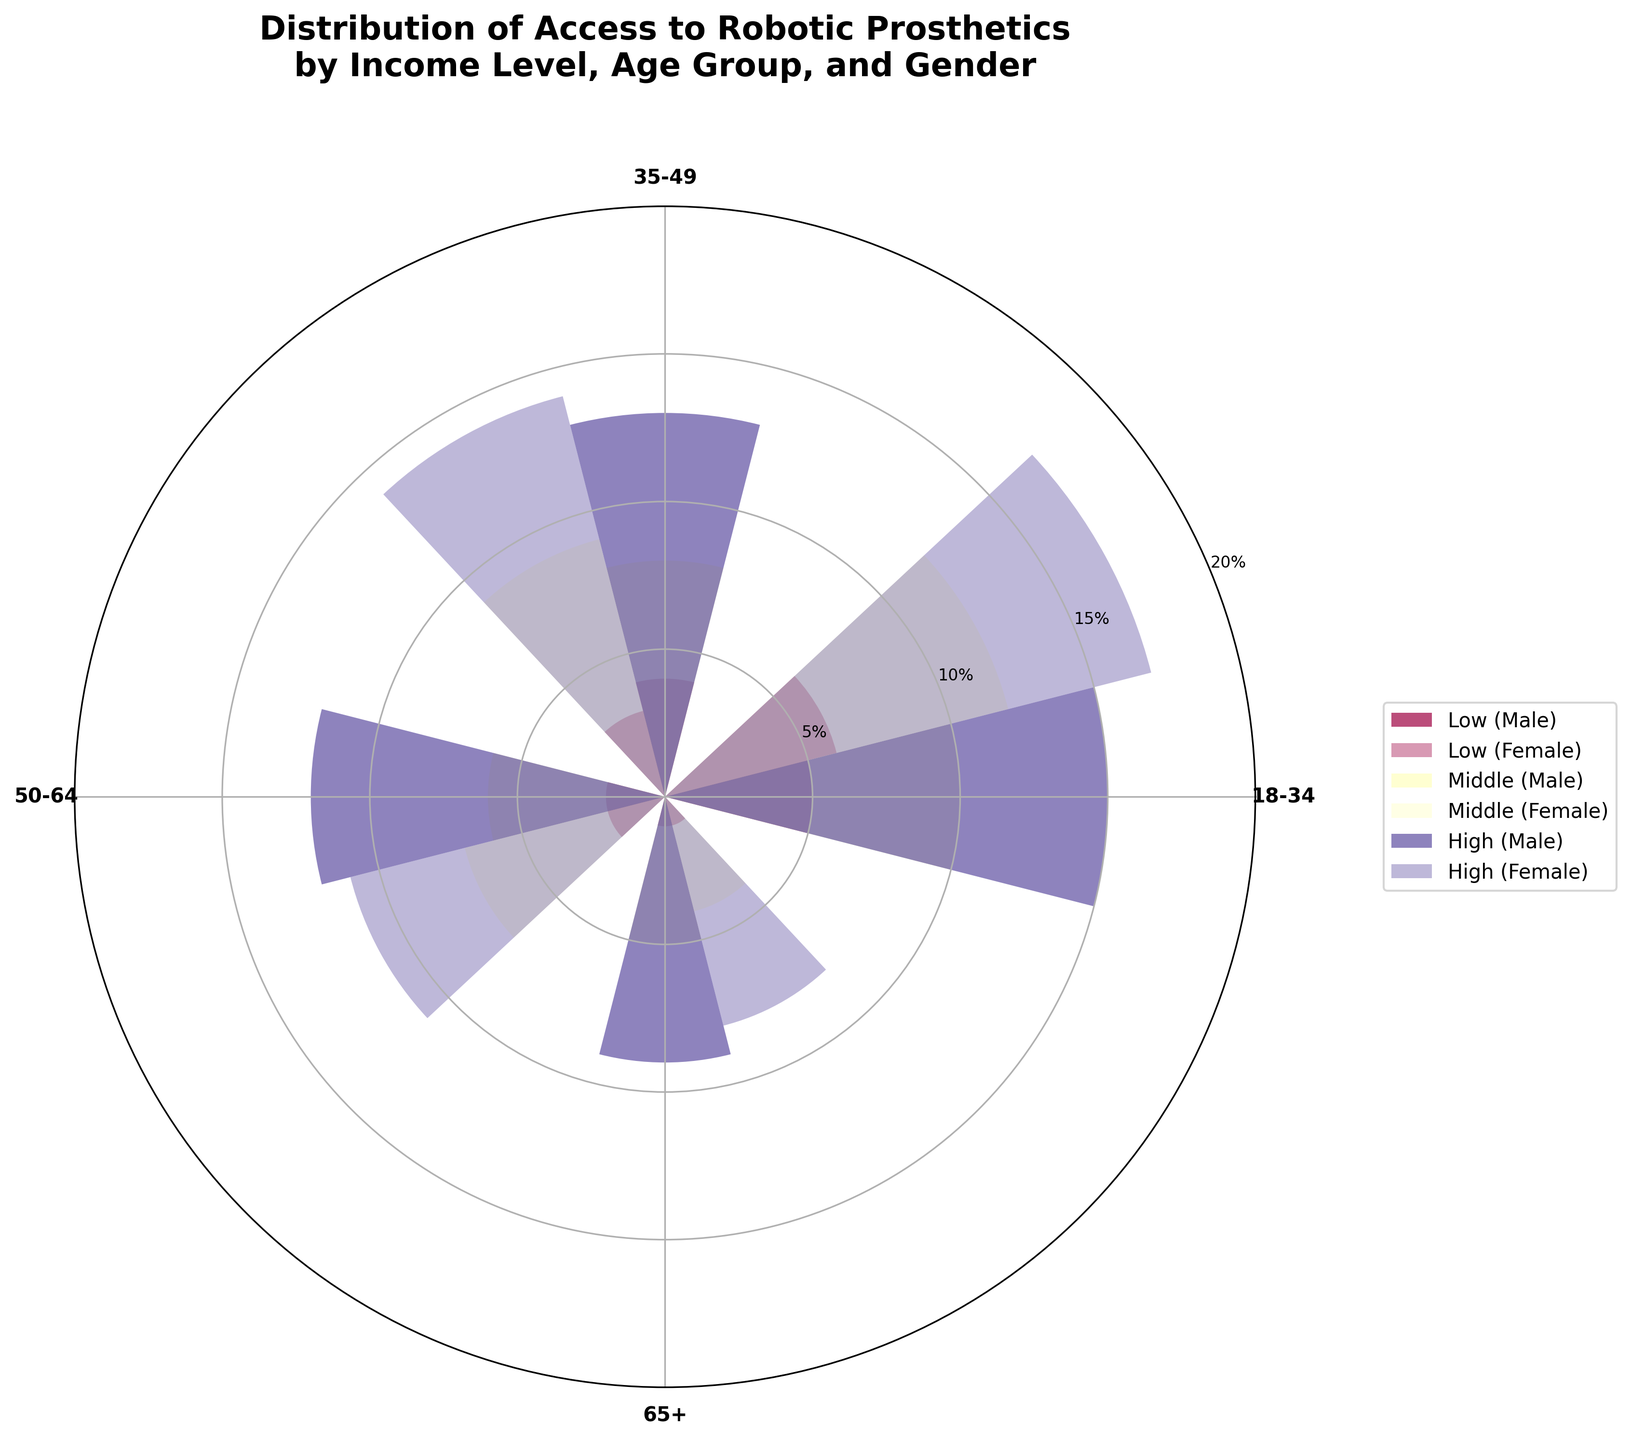What is the title of the chart? The title is usually located at the top of the chart and describes what the chart is about.
Answer: Distribution of Access to Robotic Prosthetics by Income Level, Age Group, and Gender Which age group has the highest access to robotic prosthetics among low-income females? Observe the age group labels and look at the bars for low-income females. The tallest bar indicates the highest access percentage.
Answer: 18-34 What is the percentage access for high-income males aged 50-64? Find the corresponding bar for the high-income males in the age group 50-64 and read the value.
Answer: 12% What is the difference in access between male and female in the middle-income group for the age group 35-49? Look at the bars for both males and females in the age group 35-49 for the middle-income group and subtract the male access percentage from the female access percentage.
Answer: 1% Which income group has the most uniform access to robotic prosthetics across all age groups? Compare the variation of access percentages across all age groups for each income level; the group with the least variation is the most uniform.
Answer: Middle How does access to robotic prosthetics differ for females from low to high income in the age group 18-34? Compare the heights of the bars for females in the age group 18-34 across low, middle, and high-income levels.
Answer: Increases from 6 to 17 For which gender and income group does access to robotic prosthetics decrease as age increases? Review the bars for each gender and income group combination to determine if the access percentage decreases consistently with increasing age.
Answer: Low-income males Which gender in the high-income group has the overall highest percentage access across age groups? Compare the heights of the bars for all age groups within the high-income group and identify the gender with the tallest individual bar(s).
Answer: Female How much higher is the access percentage for high-income females aged 18-34 compared to low-income females of the same age group? Subtract the access percentage of low-income females aged 18-34 from that of high-income females of the same age group.
Answer: 11 Which age group has the least discrepancy in access between genders in the middle-income group? Compare the differences in access percentages between males and females for each age group within the middle-income group; the smallest difference indicates the smallest discrepancy.
Answer: 18-34 